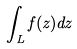Convert formula to latex. <formula><loc_0><loc_0><loc_500><loc_500>\int _ { L } f ( z ) d z</formula> 